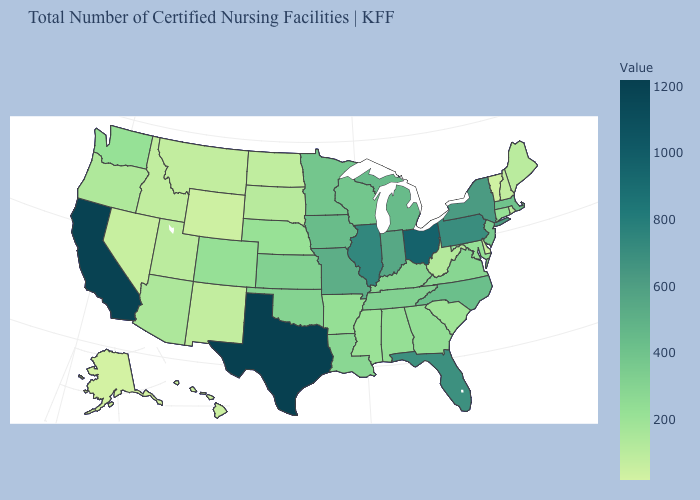Does California have the highest value in the West?
Quick response, please. Yes. Is the legend a continuous bar?
Keep it brief. Yes. Is the legend a continuous bar?
Short answer required. Yes. Which states have the highest value in the USA?
Keep it brief. Texas. Does Alaska have the lowest value in the USA?
Short answer required. Yes. Does Vermont have the lowest value in the Northeast?
Give a very brief answer. Yes. 